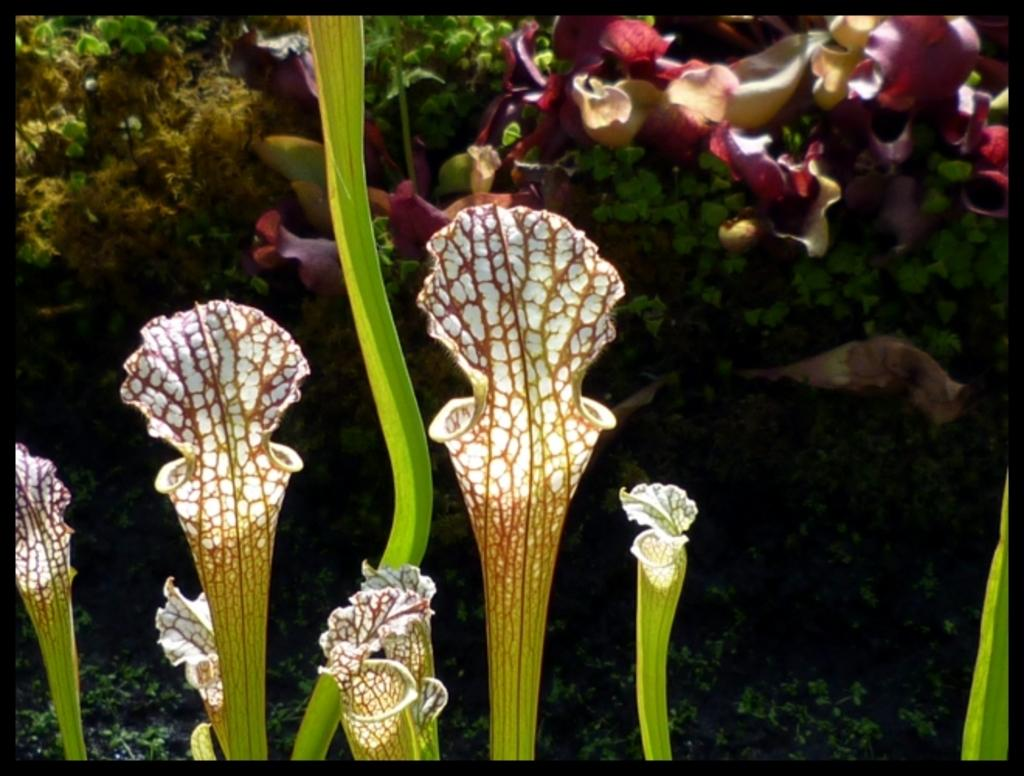What types of living organisms can be seen in the image? Flowers and plants can be seen in the image. What colors are present in the flowers and plants? The flowers and plants have different colors, including green, pink, yellow, and white. Can you see the face of the person breathing on the flowers in the image? There is no person or face present in the image, and the flowers are not being breathed on. 